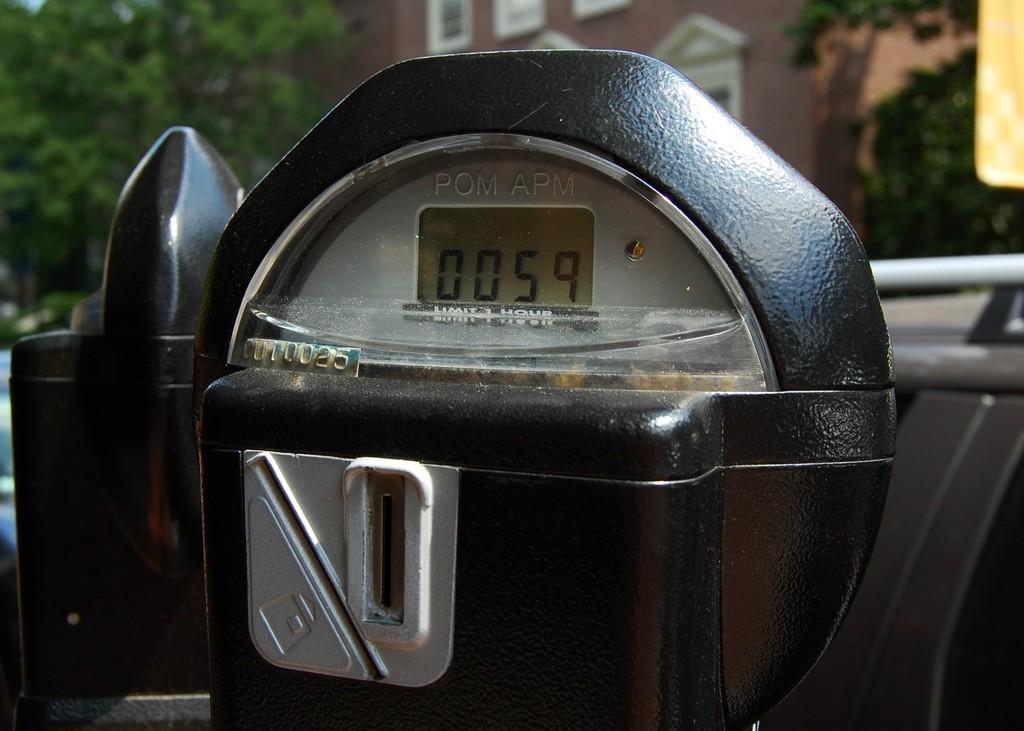How much time remains on this meter?
Keep it short and to the point. 59. 